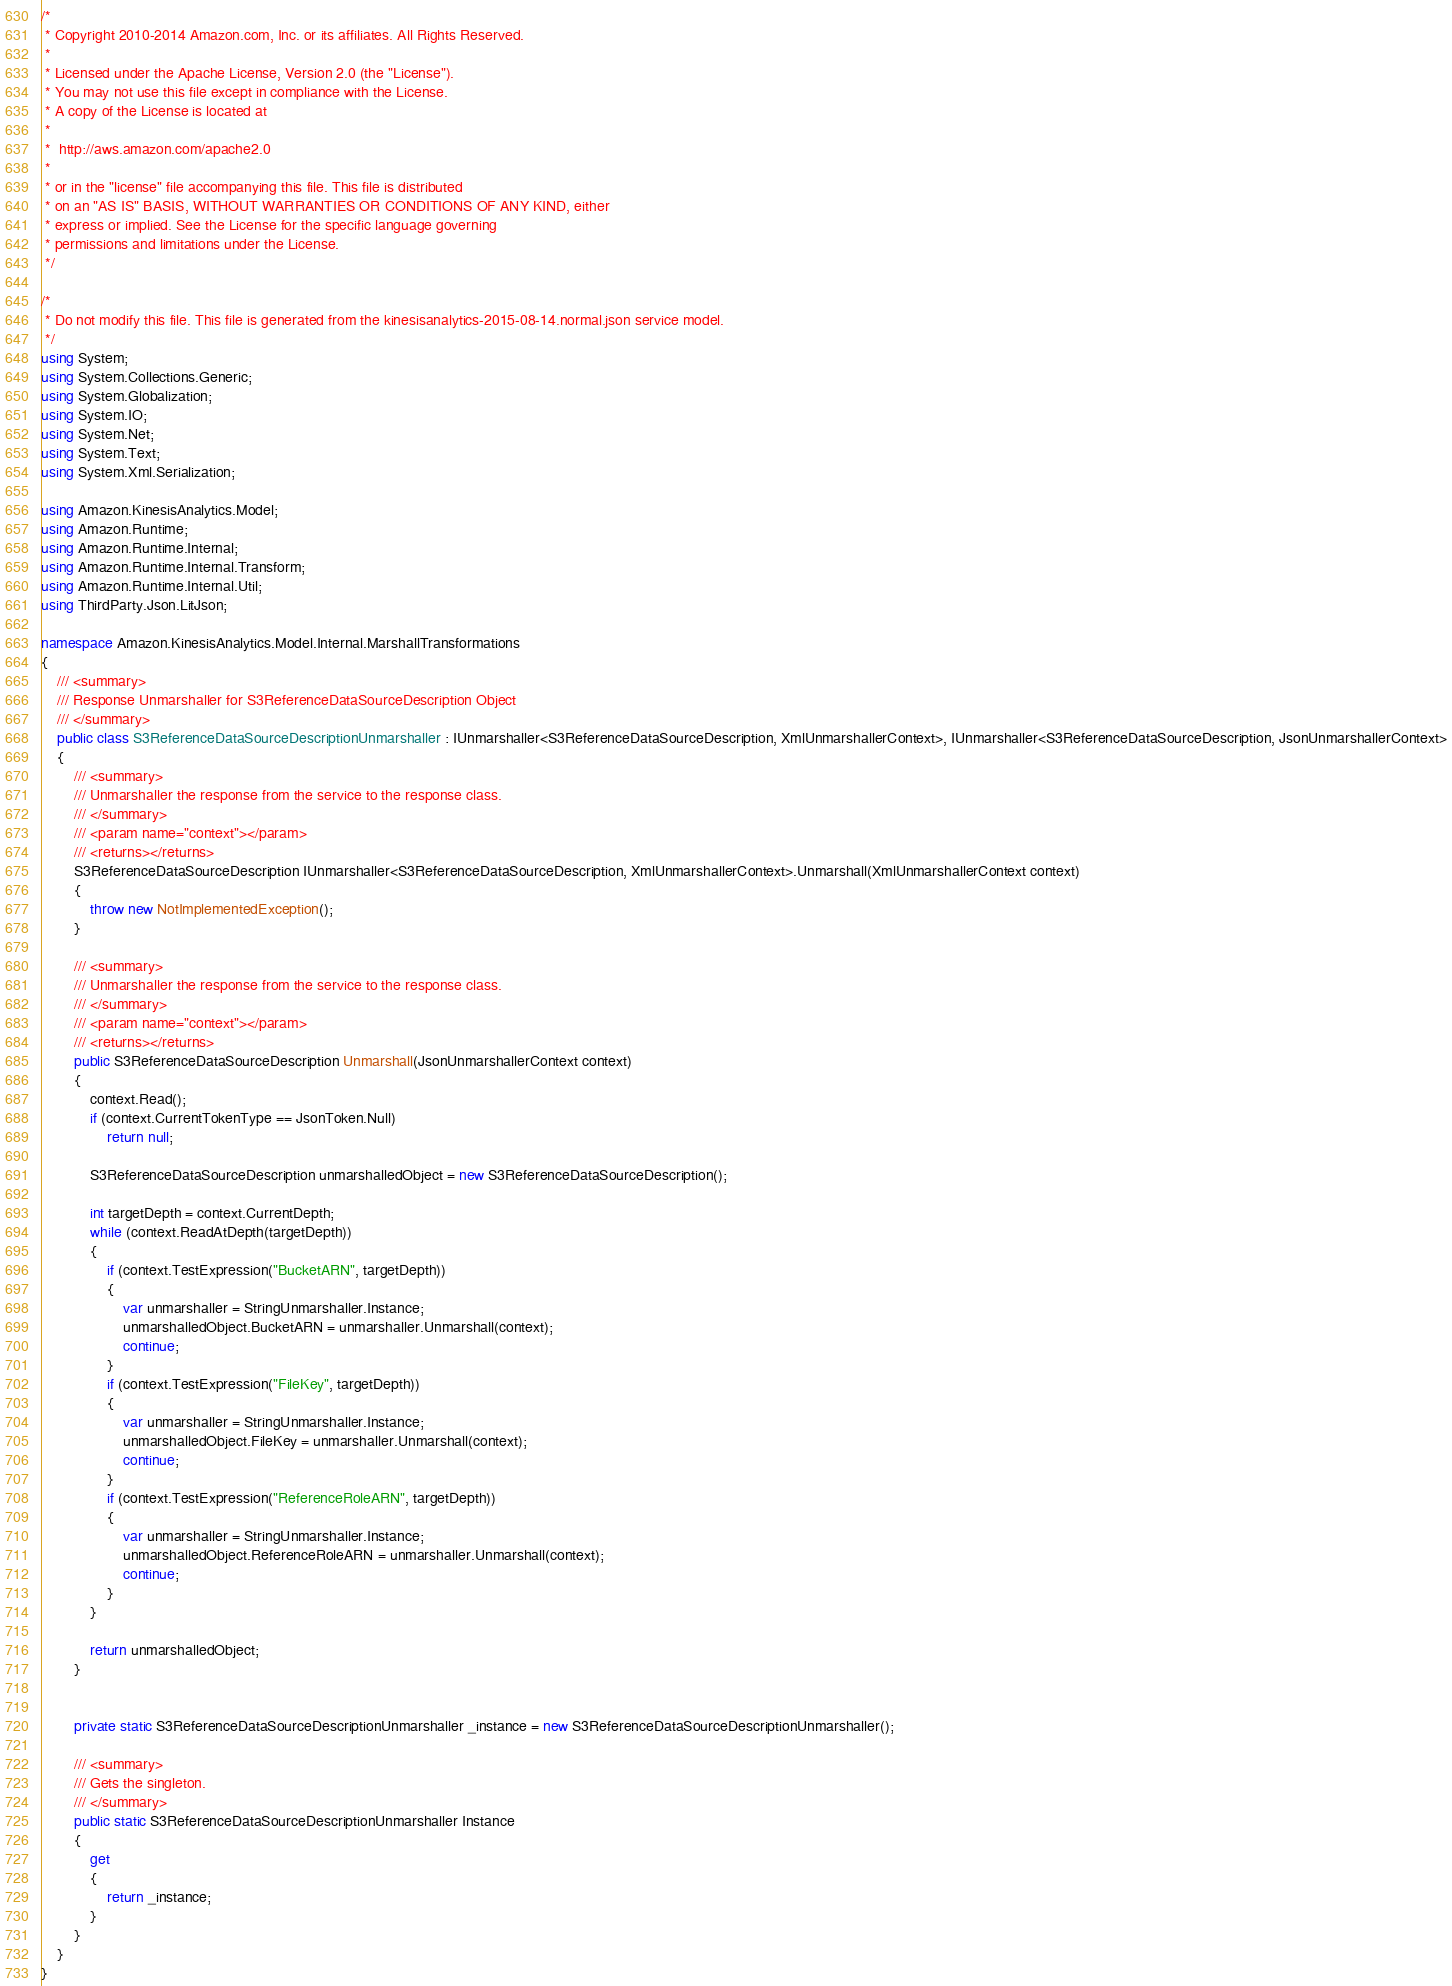<code> <loc_0><loc_0><loc_500><loc_500><_C#_>/*
 * Copyright 2010-2014 Amazon.com, Inc. or its affiliates. All Rights Reserved.
 * 
 * Licensed under the Apache License, Version 2.0 (the "License").
 * You may not use this file except in compliance with the License.
 * A copy of the License is located at
 * 
 *  http://aws.amazon.com/apache2.0
 * 
 * or in the "license" file accompanying this file. This file is distributed
 * on an "AS IS" BASIS, WITHOUT WARRANTIES OR CONDITIONS OF ANY KIND, either
 * express or implied. See the License for the specific language governing
 * permissions and limitations under the License.
 */

/*
 * Do not modify this file. This file is generated from the kinesisanalytics-2015-08-14.normal.json service model.
 */
using System;
using System.Collections.Generic;
using System.Globalization;
using System.IO;
using System.Net;
using System.Text;
using System.Xml.Serialization;

using Amazon.KinesisAnalytics.Model;
using Amazon.Runtime;
using Amazon.Runtime.Internal;
using Amazon.Runtime.Internal.Transform;
using Amazon.Runtime.Internal.Util;
using ThirdParty.Json.LitJson;

namespace Amazon.KinesisAnalytics.Model.Internal.MarshallTransformations
{
    /// <summary>
    /// Response Unmarshaller for S3ReferenceDataSourceDescription Object
    /// </summary>  
    public class S3ReferenceDataSourceDescriptionUnmarshaller : IUnmarshaller<S3ReferenceDataSourceDescription, XmlUnmarshallerContext>, IUnmarshaller<S3ReferenceDataSourceDescription, JsonUnmarshallerContext>
    {
        /// <summary>
        /// Unmarshaller the response from the service to the response class.
        /// </summary>  
        /// <param name="context"></param>
        /// <returns></returns>
        S3ReferenceDataSourceDescription IUnmarshaller<S3ReferenceDataSourceDescription, XmlUnmarshallerContext>.Unmarshall(XmlUnmarshallerContext context)
        {
            throw new NotImplementedException();
        }

        /// <summary>
        /// Unmarshaller the response from the service to the response class.
        /// </summary>  
        /// <param name="context"></param>
        /// <returns></returns>
        public S3ReferenceDataSourceDescription Unmarshall(JsonUnmarshallerContext context)
        {
            context.Read();
            if (context.CurrentTokenType == JsonToken.Null) 
                return null;

            S3ReferenceDataSourceDescription unmarshalledObject = new S3ReferenceDataSourceDescription();
        
            int targetDepth = context.CurrentDepth;
            while (context.ReadAtDepth(targetDepth))
            {
                if (context.TestExpression("BucketARN", targetDepth))
                {
                    var unmarshaller = StringUnmarshaller.Instance;
                    unmarshalledObject.BucketARN = unmarshaller.Unmarshall(context);
                    continue;
                }
                if (context.TestExpression("FileKey", targetDepth))
                {
                    var unmarshaller = StringUnmarshaller.Instance;
                    unmarshalledObject.FileKey = unmarshaller.Unmarshall(context);
                    continue;
                }
                if (context.TestExpression("ReferenceRoleARN", targetDepth))
                {
                    var unmarshaller = StringUnmarshaller.Instance;
                    unmarshalledObject.ReferenceRoleARN = unmarshaller.Unmarshall(context);
                    continue;
                }
            }
          
            return unmarshalledObject;
        }


        private static S3ReferenceDataSourceDescriptionUnmarshaller _instance = new S3ReferenceDataSourceDescriptionUnmarshaller();        

        /// <summary>
        /// Gets the singleton.
        /// </summary>  
        public static S3ReferenceDataSourceDescriptionUnmarshaller Instance
        {
            get
            {
                return _instance;
            }
        }
    }
}</code> 